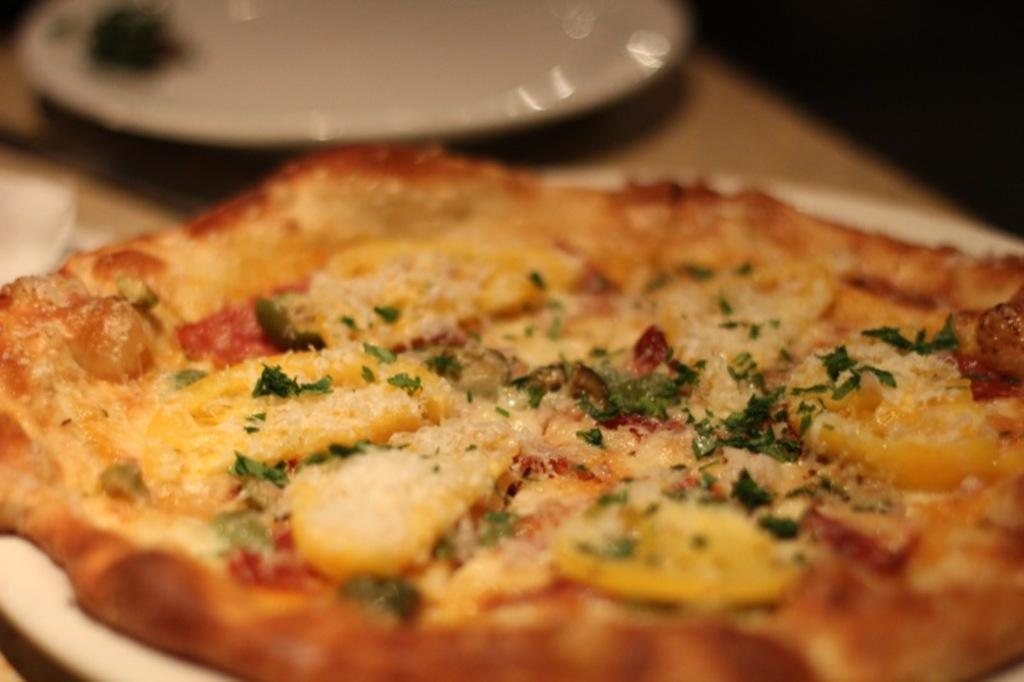What type of food is on the plate in the image? There is a pizza on a plate in the image. Can you describe the other plate on the table in the image? There is another plate on the table in the image, but its contents are not specified. What type of print can be seen on the country in the image? There is no country or print present in the image; it features a pizza on a plate and another plate on a table. 